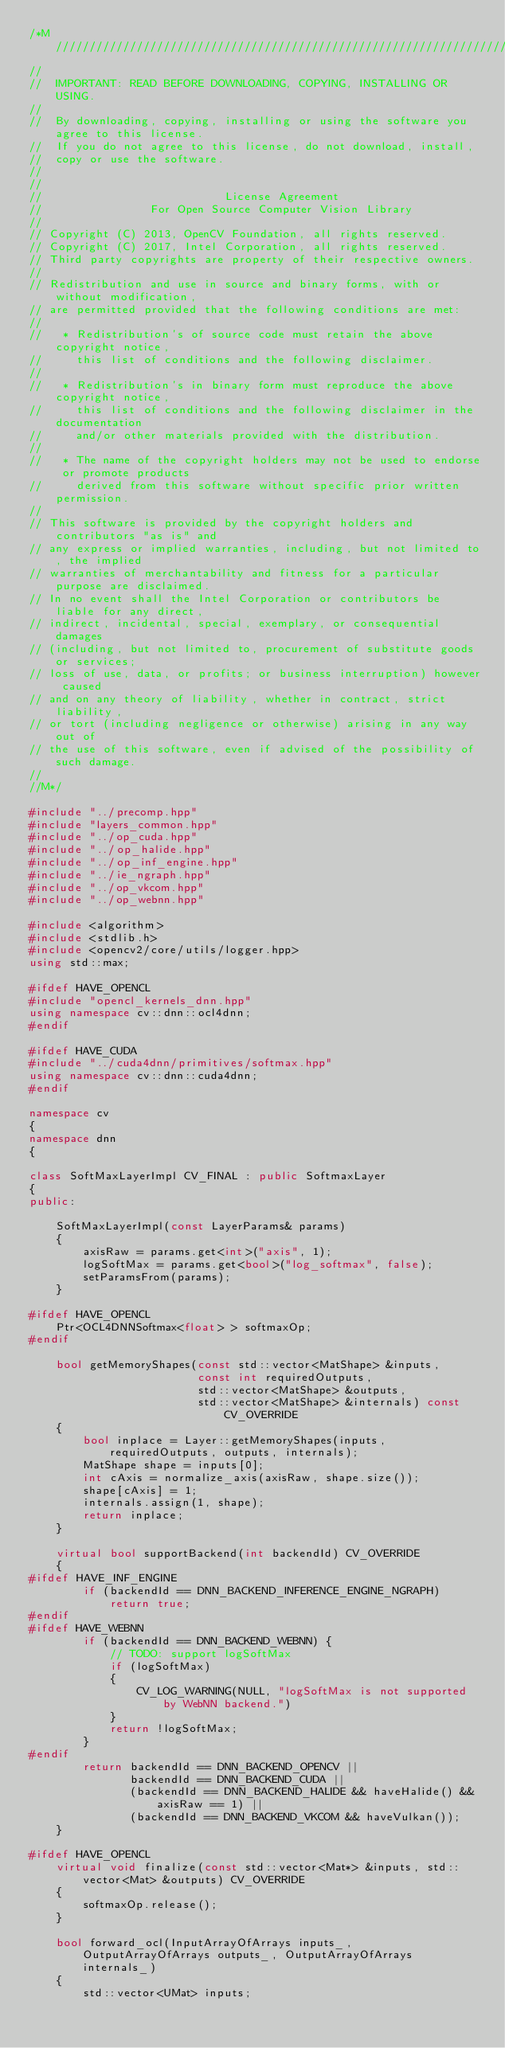<code> <loc_0><loc_0><loc_500><loc_500><_C++_>/*M///////////////////////////////////////////////////////////////////////////////////////
//
//  IMPORTANT: READ BEFORE DOWNLOADING, COPYING, INSTALLING OR USING.
//
//  By downloading, copying, installing or using the software you agree to this license.
//  If you do not agree to this license, do not download, install,
//  copy or use the software.
//
//
//                           License Agreement
//                For Open Source Computer Vision Library
//
// Copyright (C) 2013, OpenCV Foundation, all rights reserved.
// Copyright (C) 2017, Intel Corporation, all rights reserved.
// Third party copyrights are property of their respective owners.
//
// Redistribution and use in source and binary forms, with or without modification,
// are permitted provided that the following conditions are met:
//
//   * Redistribution's of source code must retain the above copyright notice,
//     this list of conditions and the following disclaimer.
//
//   * Redistribution's in binary form must reproduce the above copyright notice,
//     this list of conditions and the following disclaimer in the documentation
//     and/or other materials provided with the distribution.
//
//   * The name of the copyright holders may not be used to endorse or promote products
//     derived from this software without specific prior written permission.
//
// This software is provided by the copyright holders and contributors "as is" and
// any express or implied warranties, including, but not limited to, the implied
// warranties of merchantability and fitness for a particular purpose are disclaimed.
// In no event shall the Intel Corporation or contributors be liable for any direct,
// indirect, incidental, special, exemplary, or consequential damages
// (including, but not limited to, procurement of substitute goods or services;
// loss of use, data, or profits; or business interruption) however caused
// and on any theory of liability, whether in contract, strict liability,
// or tort (including negligence or otherwise) arising in any way out of
// the use of this software, even if advised of the possibility of such damage.
//
//M*/

#include "../precomp.hpp"
#include "layers_common.hpp"
#include "../op_cuda.hpp"
#include "../op_halide.hpp"
#include "../op_inf_engine.hpp"
#include "../ie_ngraph.hpp"
#include "../op_vkcom.hpp"
#include "../op_webnn.hpp"

#include <algorithm>
#include <stdlib.h>
#include <opencv2/core/utils/logger.hpp>
using std::max;

#ifdef HAVE_OPENCL
#include "opencl_kernels_dnn.hpp"
using namespace cv::dnn::ocl4dnn;
#endif

#ifdef HAVE_CUDA
#include "../cuda4dnn/primitives/softmax.hpp"
using namespace cv::dnn::cuda4dnn;
#endif

namespace cv
{
namespace dnn
{

class SoftMaxLayerImpl CV_FINAL : public SoftmaxLayer
{
public:

    SoftMaxLayerImpl(const LayerParams& params)
    {
        axisRaw = params.get<int>("axis", 1);
        logSoftMax = params.get<bool>("log_softmax", false);
        setParamsFrom(params);
    }

#ifdef HAVE_OPENCL
    Ptr<OCL4DNNSoftmax<float> > softmaxOp;
#endif

    bool getMemoryShapes(const std::vector<MatShape> &inputs,
                         const int requiredOutputs,
                         std::vector<MatShape> &outputs,
                         std::vector<MatShape> &internals) const CV_OVERRIDE
    {
        bool inplace = Layer::getMemoryShapes(inputs, requiredOutputs, outputs, internals);
        MatShape shape = inputs[0];
        int cAxis = normalize_axis(axisRaw, shape.size());
        shape[cAxis] = 1;
        internals.assign(1, shape);
        return inplace;
    }

    virtual bool supportBackend(int backendId) CV_OVERRIDE
    {
#ifdef HAVE_INF_ENGINE
        if (backendId == DNN_BACKEND_INFERENCE_ENGINE_NGRAPH)
            return true;
#endif
#ifdef HAVE_WEBNN
        if (backendId == DNN_BACKEND_WEBNN) {
            // TODO: support logSoftMax
            if (logSoftMax)
            {
                CV_LOG_WARNING(NULL, "logSoftMax is not supported by WebNN backend.")
            }
            return !logSoftMax;
        }
#endif
        return backendId == DNN_BACKEND_OPENCV ||
               backendId == DNN_BACKEND_CUDA ||
               (backendId == DNN_BACKEND_HALIDE && haveHalide() && axisRaw == 1) ||
               (backendId == DNN_BACKEND_VKCOM && haveVulkan());
    }

#ifdef HAVE_OPENCL
    virtual void finalize(const std::vector<Mat*> &inputs, std::vector<Mat> &outputs) CV_OVERRIDE
    {
        softmaxOp.release();
    }

    bool forward_ocl(InputArrayOfArrays inputs_, OutputArrayOfArrays outputs_, OutputArrayOfArrays internals_)
    {
        std::vector<UMat> inputs;</code> 